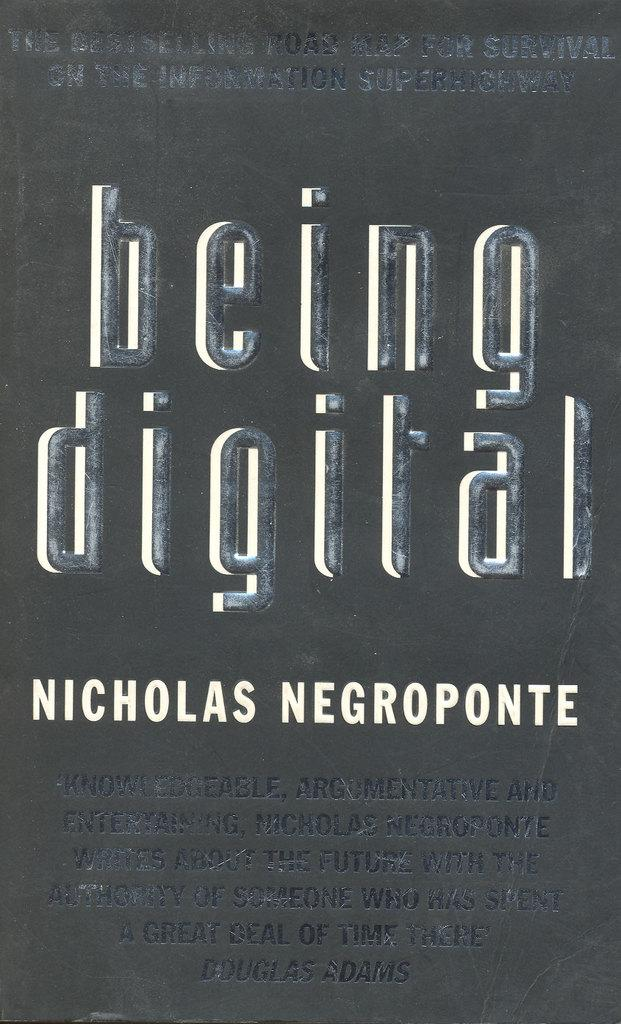<image>
Share a concise interpretation of the image provided. The book being digital is a best selling book. 